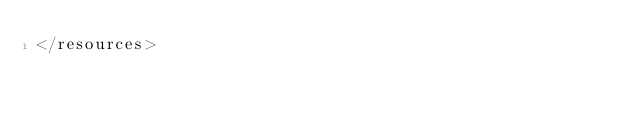Convert code to text. <code><loc_0><loc_0><loc_500><loc_500><_XML_></resources></code> 